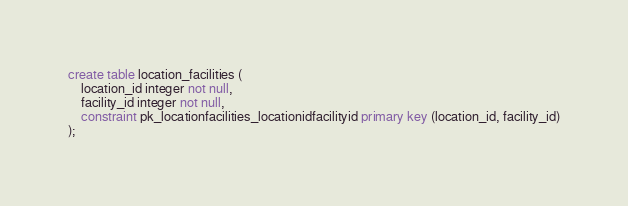Convert code to text. <code><loc_0><loc_0><loc_500><loc_500><_SQL_>create table location_facilities (
    location_id integer not null,
    facility_id integer not null,
    constraint pk_locationfacilities_locationidfacilityid primary key (location_id, facility_id)
);</code> 